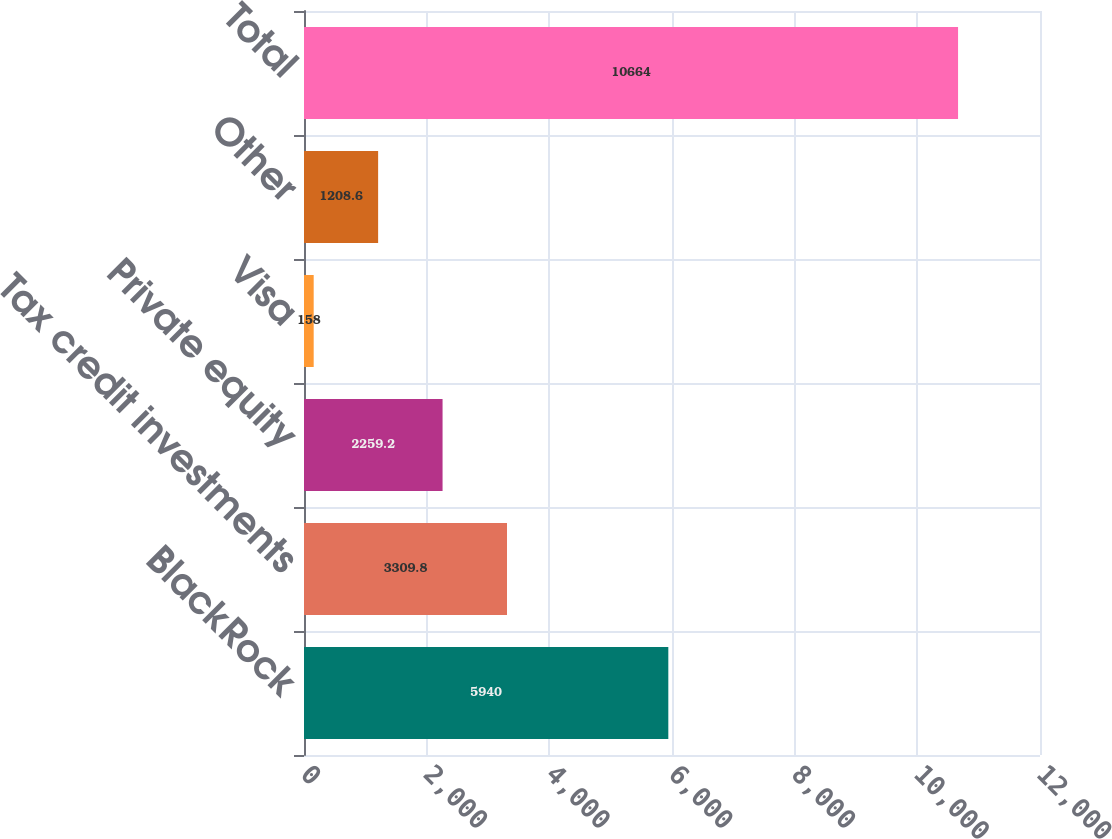Convert chart to OTSL. <chart><loc_0><loc_0><loc_500><loc_500><bar_chart><fcel>BlackRock<fcel>Tax credit investments<fcel>Private equity<fcel>Visa<fcel>Other<fcel>Total<nl><fcel>5940<fcel>3309.8<fcel>2259.2<fcel>158<fcel>1208.6<fcel>10664<nl></chart> 